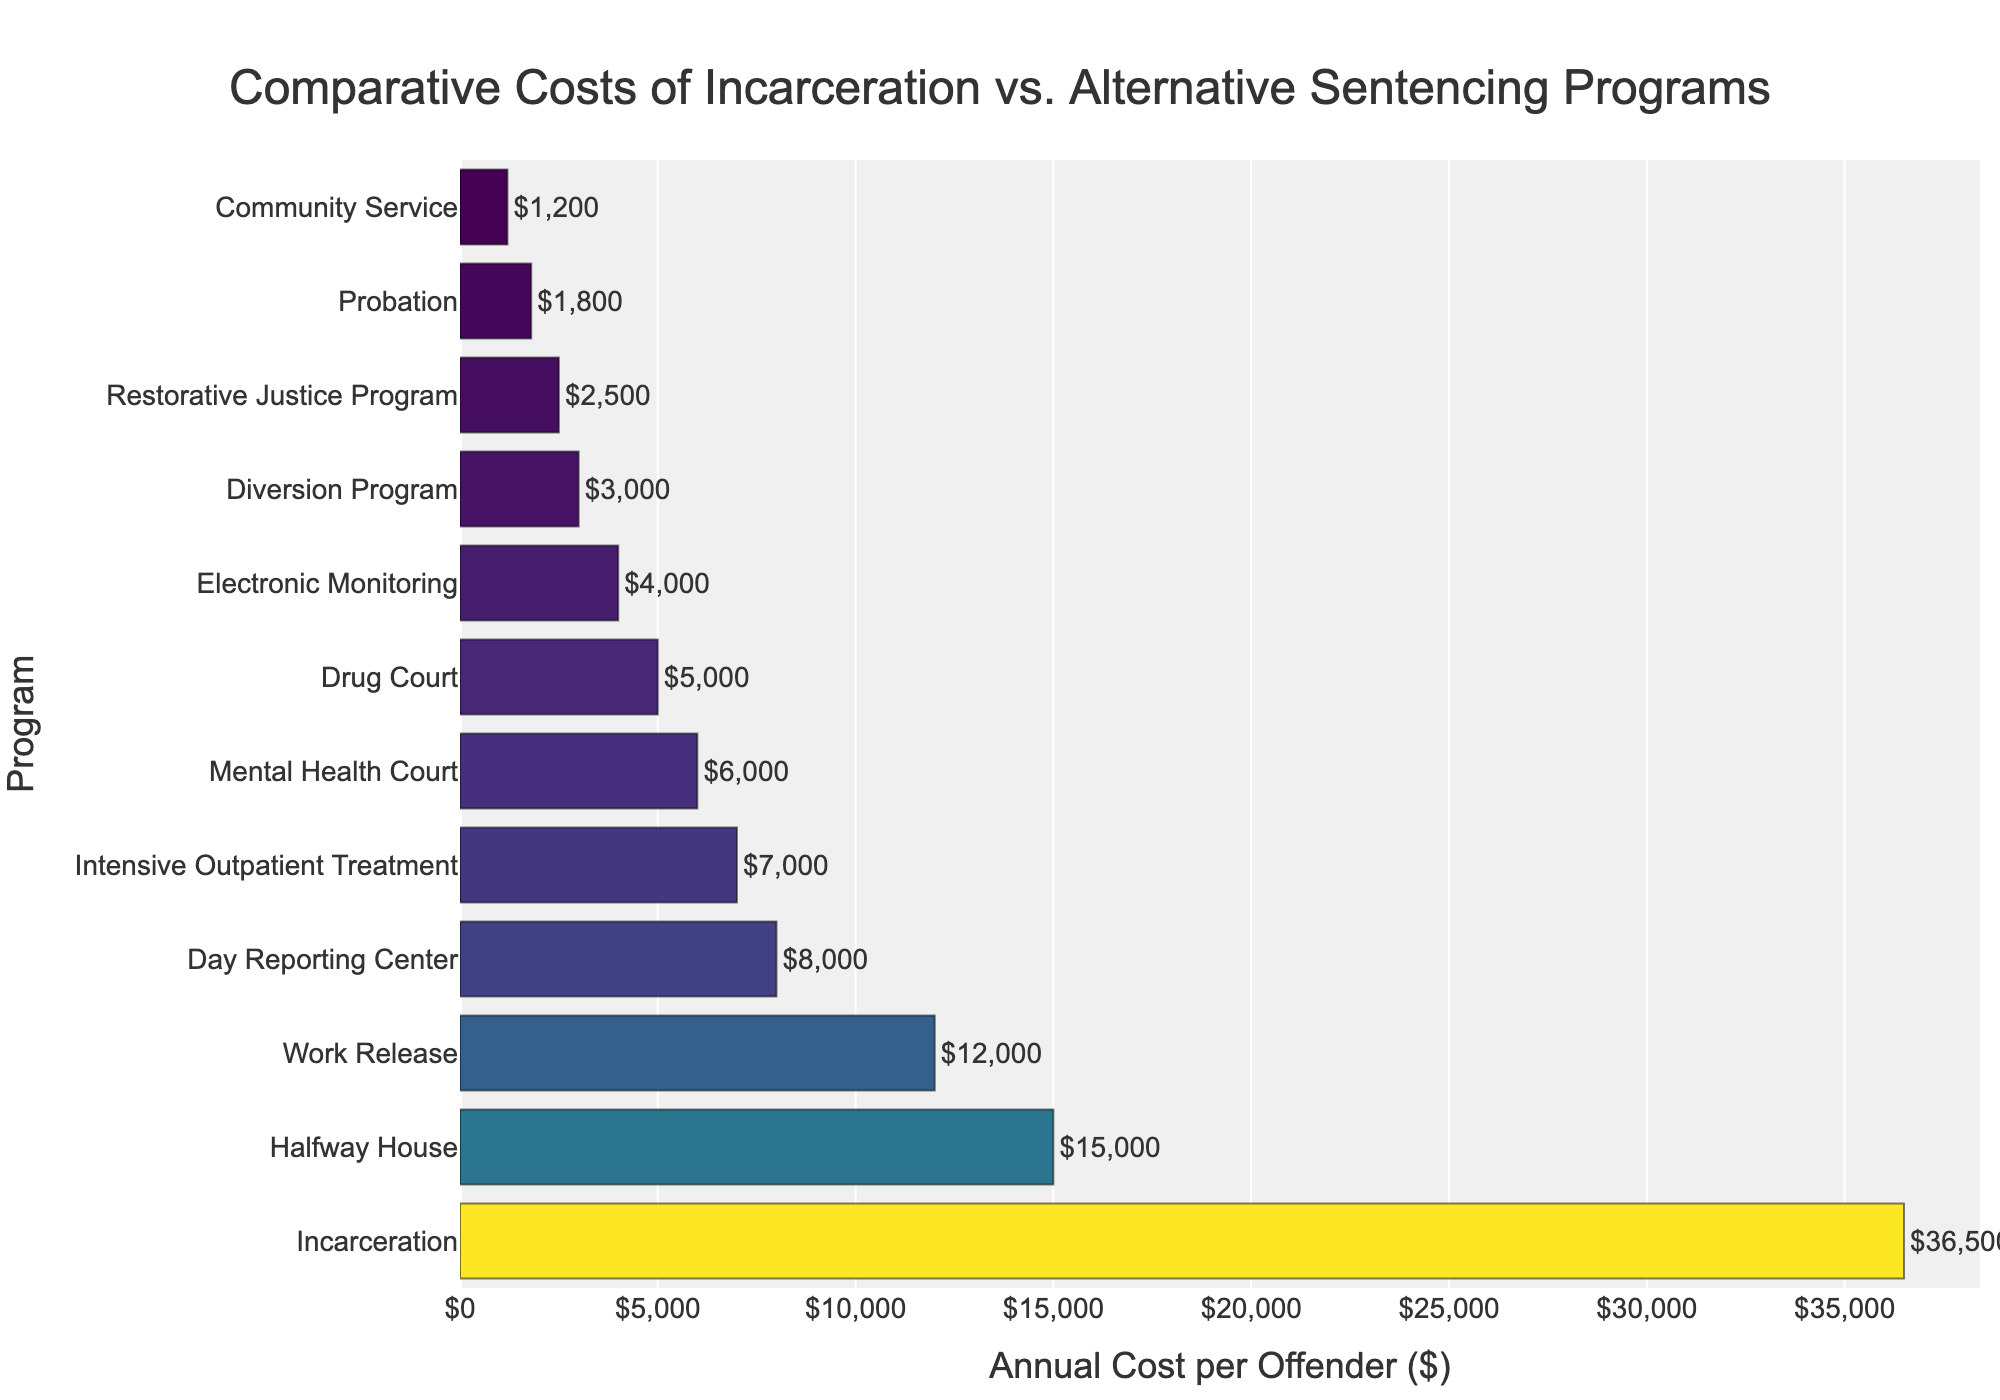Which program has the highest annual cost per offender? By observing the bar chart, the longest bar represents the program with the highest cost. In this case, the longest bar corresponds to 'Incarceration', indicating it has the highest cost.
Answer: Incarceration Which program has the lowest annual cost per offender? The shortest bar in the chart represents the program with the lowest cost. Here, the shortest bar corresponds to 'Community Service'.
Answer: Community Service How much more does incarceration cost per offender compared to probation? Subtract the cost of probation from the cost of incarceration. The cost of incarceration is $36,500 and the cost of probation is $1,800, so the difference is $36,500 - $1,800.
Answer: $34,700 What is the total cost per offender for Electronic Monitoring, Drug Court, and Community Service combined? Add the costs of Electronic Monitoring, Drug Court, and Community Service. The costs are $4,000, $5,000, and $1,200 respectively. Total is $4,000 + $5,000 + $1,200.
Answer: $10,200 How does the cost of Mental Health Court compare to Halfway House? Compare the lengths of the bars for Mental Health Court and Halfway House. The annual cost for Mental Health Court is $6,000, and for Halfway House, it is $15,000. Mental Health Court costs less.
Answer: Mental Health Court is cheaper Which alternative sentencing program appears to be the most cost-effective based on the chart? The bar with the shortest length corresponds to the most cost-effective program. 'Community Service' has the shortest bar with a cost of $1,200.
Answer: Community Service What is the average annual cost per offender for Drug Court, Intensive Outpatient Treatment, and Day Reporting Center? Calculate the average of the three costs. Add the costs ($5,000 + $7,000 + $8,000) and divide by the number of programs (3). Average = ($5,000 + $7,000 + $8,000) / 3.
Answer: $6,666.67 Which programs cost less than $5,000 per offender annually? Identify the bars that are shorter than the bar representing $5,000. The programs are Probation ($1,800), Electronic Monitoring ($4,000), Community Service ($1,200), Restorative Justice Program ($2,500), and Diversion Program ($3,000).
Answer: Probation, Electronic Monitoring, Community Service, Restorative Justice Program, Diversion Program By how much does the cost of Intensive Outpatient Treatment exceed the cost of the Restorative Justice Program? Subtract the cost of Restorative Justice Program ($2,500) from the cost of Intensive Outpatient Treatment ($7,000). The difference is $7,000 - $2,500.
Answer: $4,500 What proportion of the cost of incarceration is covered by the cost of Electronic Monitoring? Divide the cost of Electronic Monitoring ($4,000) by the cost of Incarceration ($36,500) and multiply by 100 to get the percentage. Calculation: ($4,000 / $36,500) * 100.
Answer: Approximately 11% 